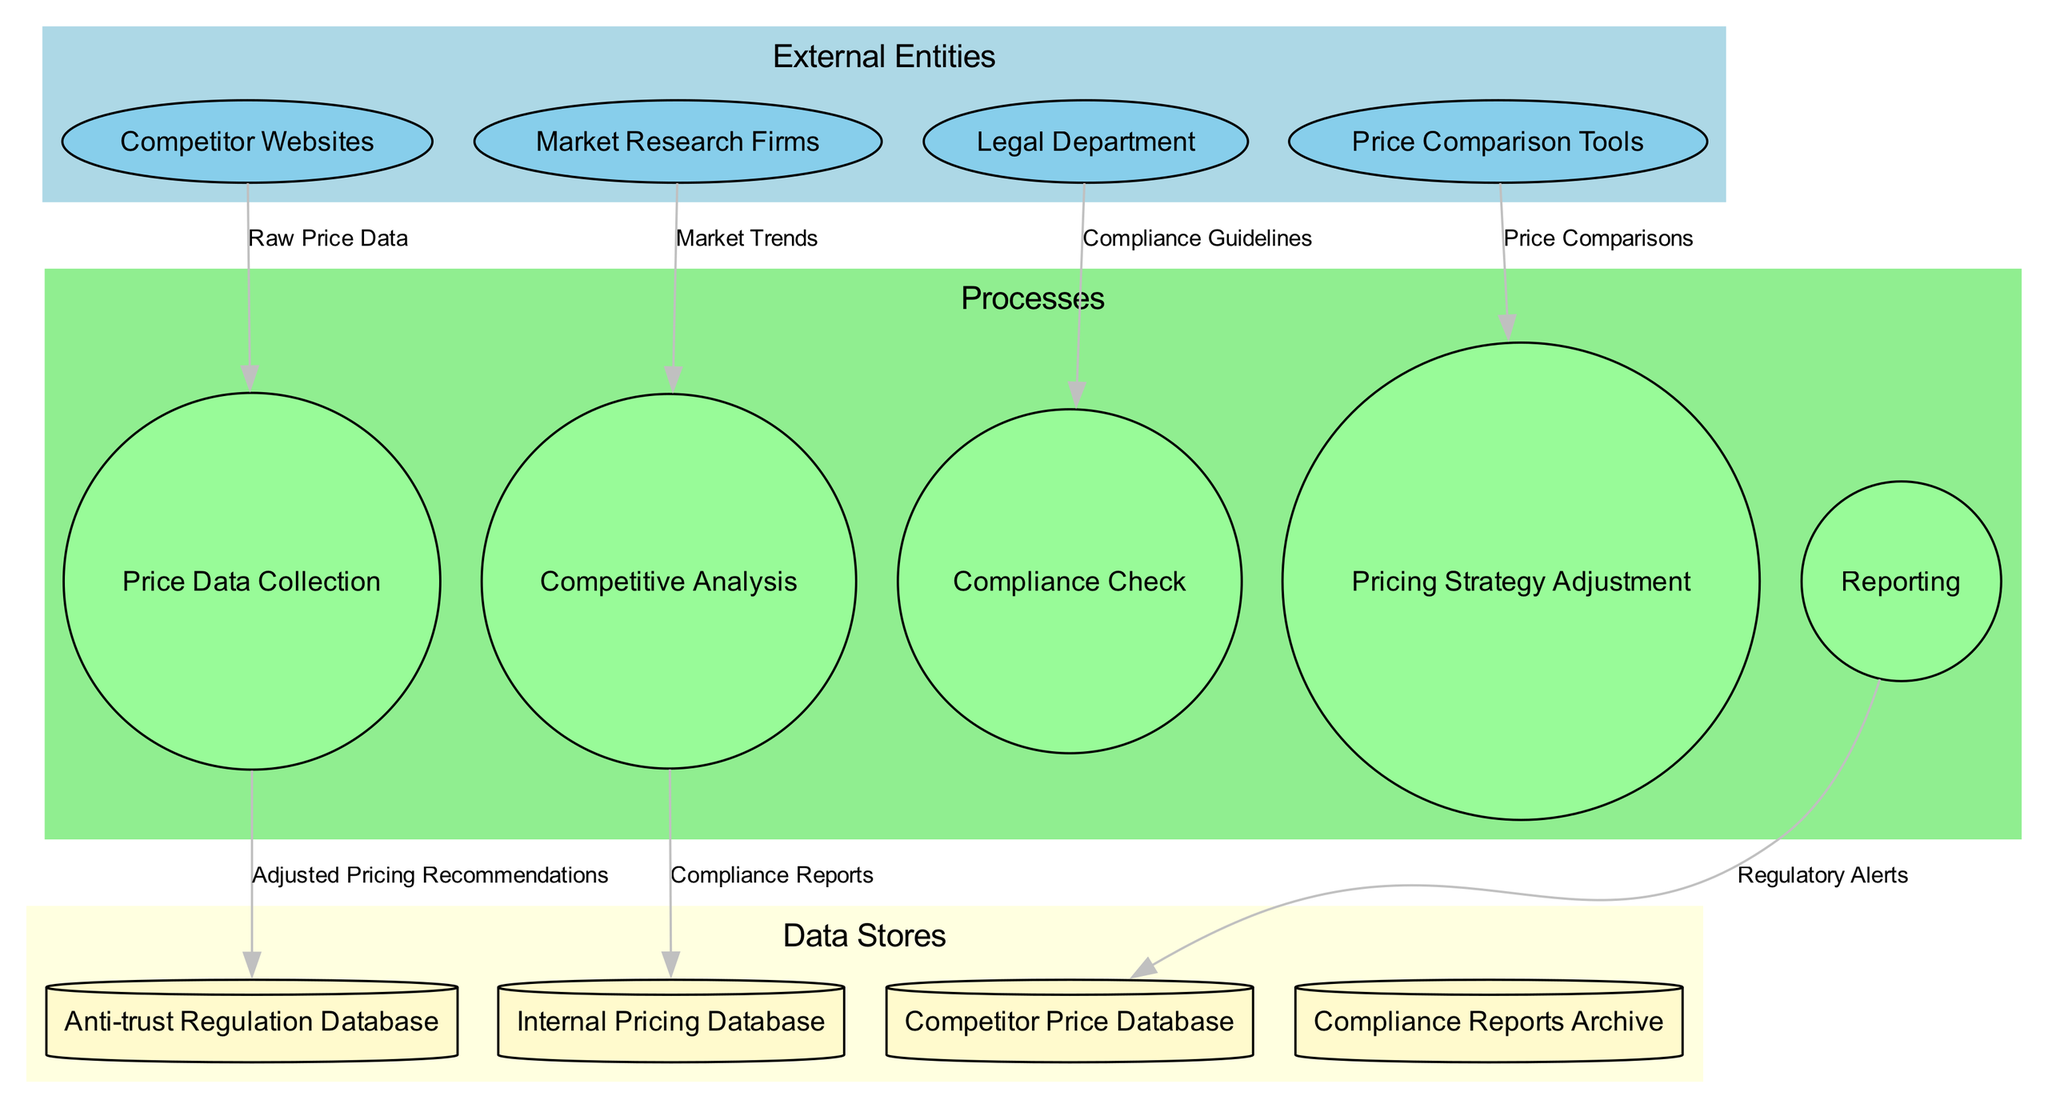What are the external entities in the diagram? The external entities are listed in the "External Entities" section of the diagram. They include "Competitor Websites," "Market Research Firms," "Legal Department," and "Price Comparison Tools."
Answer: Competitor Websites, Market Research Firms, Legal Department, Price Comparison Tools How many processes are represented in the diagram? The processes are found in the "Processes" section. There are five processes: "Price Data Collection," "Competitive Analysis," "Compliance Check," "Pricing Strategy Adjustment," and "Reporting."
Answer: Five Which process receives raw price data? The flow of data indicates that raw price data is directed to the "Price Data Collection" process from "Competitor Websites." Thus, this process is the one that receives the raw price data.
Answer: Price Data Collection What is the data flow from the "Anti-trust Regulation Database"? The "Anti-trust Regulation Database" stores compliance guidelines which are passed to the "Compliance Check" process for verification against regulatory standards.
Answer: Compliance Guidelines Which data store is associated with compliance reports? The data store specifically mentioned for compliance reports is "Compliance Reports Archive." This indicates it holds all archived reports related to compliance.
Answer: Compliance Reports Archive What follows after the "Compliance Check" process regarding pricing strategies? After the "Compliance Check" process, there is an output flow that leads to the "Pricing Strategy Adjustment" process, indicating that adjustments are made based on compliance status.
Answer: Pricing Strategy Adjustment Which external entity provides market trends? The "Market Research Firms" external entity is responsible for providing insights and data related to market trends to the system.
Answer: Market Research Firms How many data flows are shown in the diagram? The data flows are represented as connections in the diagram, and there are seven distinct flows indicated: "Raw Price Data," "Market Trends," "Compliance Guidelines," "Price Comparisons," "Regulatory Alerts," "Adjusted Pricing Recommendations," and "Compliance Reports."
Answer: Seven What is the purpose of the "Competitive Analysis" process? The "Competitive Analysis" process interprets price comparisons, allowing the system to evaluate competitor pricing and market positioning. This step is crucial for forming compliant pricing strategies.
Answer: Interpret price comparisons 